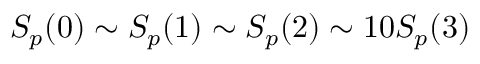<formula> <loc_0><loc_0><loc_500><loc_500>S _ { p } ( 0 ) \sim S _ { p } ( 1 ) \sim S _ { p } ( 2 ) \sim 1 0 S _ { p } ( 3 )</formula> 